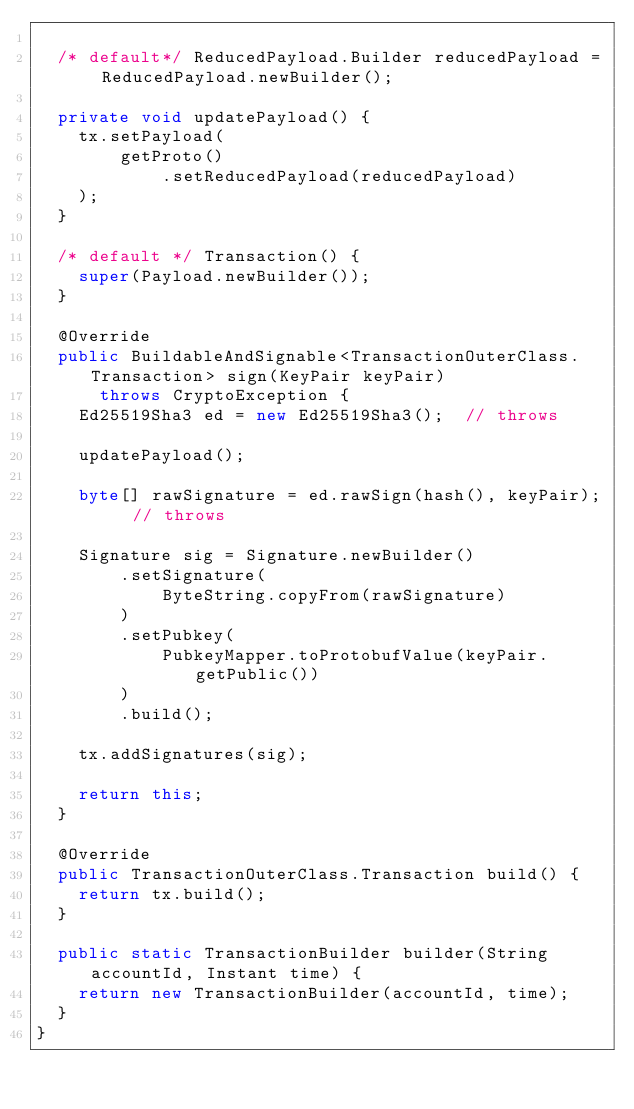<code> <loc_0><loc_0><loc_500><loc_500><_Java_>
  /* default*/ ReducedPayload.Builder reducedPayload = ReducedPayload.newBuilder();

  private void updatePayload() {
    tx.setPayload(
        getProto()
            .setReducedPayload(reducedPayload)
    );
  }

  /* default */ Transaction() {
    super(Payload.newBuilder());
  }

  @Override
  public BuildableAndSignable<TransactionOuterClass.Transaction> sign(KeyPair keyPair)
      throws CryptoException {
    Ed25519Sha3 ed = new Ed25519Sha3();  // throws

    updatePayload();

    byte[] rawSignature = ed.rawSign(hash(), keyPair);  // throws

    Signature sig = Signature.newBuilder()
        .setSignature(
            ByteString.copyFrom(rawSignature)
        )
        .setPubkey(
            PubkeyMapper.toProtobufValue(keyPair.getPublic())
        )
        .build();

    tx.addSignatures(sig);

    return this;
  }

  @Override
  public TransactionOuterClass.Transaction build() {
    return tx.build();
  }

  public static TransactionBuilder builder(String accountId, Instant time) {
    return new TransactionBuilder(accountId, time);
  }
}
</code> 